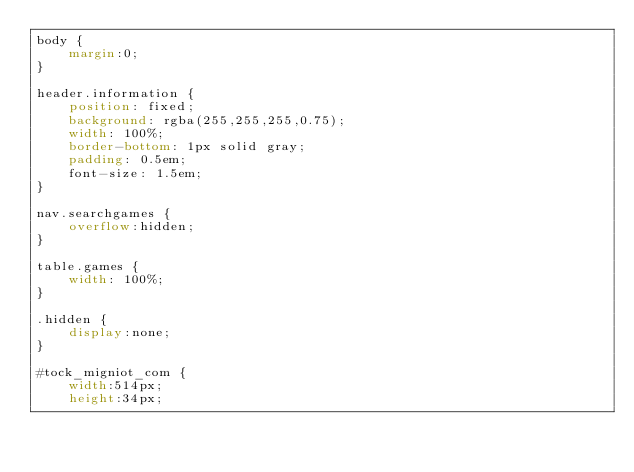Convert code to text. <code><loc_0><loc_0><loc_500><loc_500><_CSS_>body {
    margin:0;
}

header.information {
    position: fixed;
    background: rgba(255,255,255,0.75);
    width: 100%;
    border-bottom: 1px solid gray;
    padding: 0.5em;
    font-size: 1.5em;
}

nav.searchgames {
    overflow:hidden;
}

table.games {
    width: 100%;
}

.hidden {
    display:none;
}

#tock_migniot_com {
    width:514px;
    height:34px;</code> 